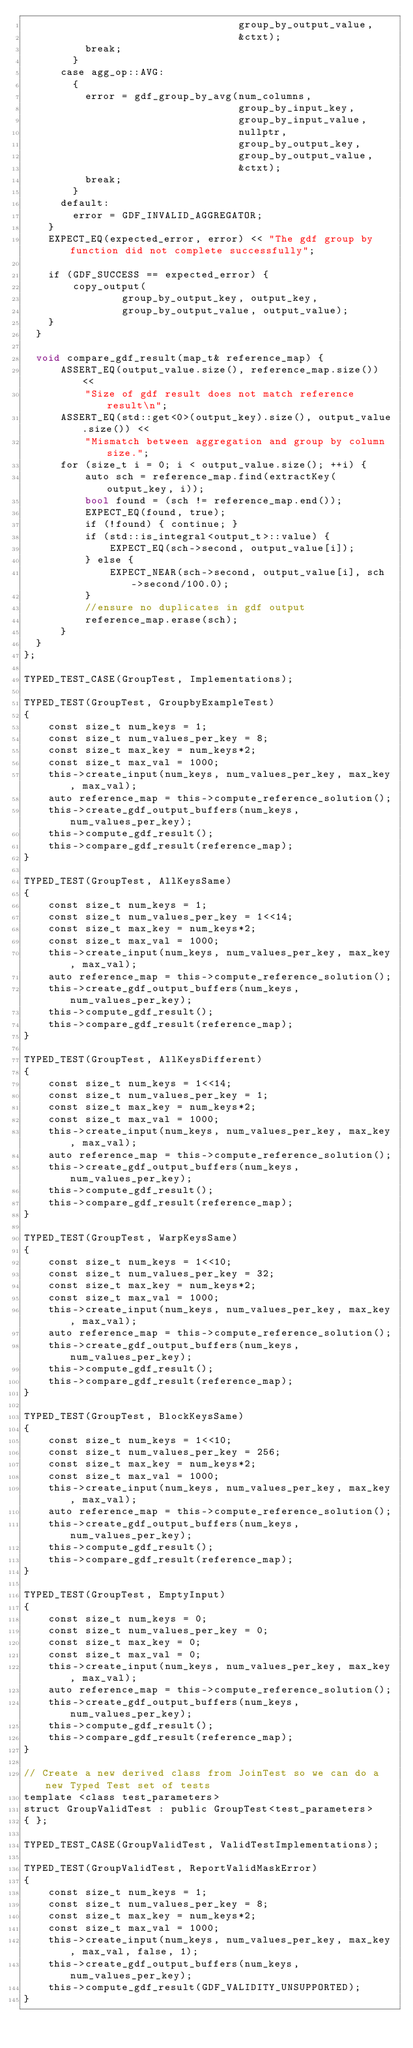<code> <loc_0><loc_0><loc_500><loc_500><_Cuda_>                                   group_by_output_value,
                                   &ctxt);
          break;
        }
      case agg_op::AVG:
        {
          error = gdf_group_by_avg(num_columns,
                                   group_by_input_key,
                                   group_by_input_value,
                                   nullptr,
                                   group_by_output_key,
                                   group_by_output_value,
                                   &ctxt);
          break;
        }
      default:
        error = GDF_INVALID_AGGREGATOR;
    }
    EXPECT_EQ(expected_error, error) << "The gdf group by function did not complete successfully";

    if (GDF_SUCCESS == expected_error) {
        copy_output(
                group_by_output_key, output_key,
                group_by_output_value, output_value);
    }
  }

  void compare_gdf_result(map_t& reference_map) {
      ASSERT_EQ(output_value.size(), reference_map.size()) <<
          "Size of gdf result does not match reference result\n";
      ASSERT_EQ(std::get<0>(output_key).size(), output_value.size()) <<
          "Mismatch between aggregation and group by column size.";
      for (size_t i = 0; i < output_value.size(); ++i) {
          auto sch = reference_map.find(extractKey(output_key, i));
          bool found = (sch != reference_map.end());
          EXPECT_EQ(found, true);
          if (!found) { continue; }
          if (std::is_integral<output_t>::value) {
              EXPECT_EQ(sch->second, output_value[i]);
          } else {
              EXPECT_NEAR(sch->second, output_value[i], sch->second/100.0);
          }
          //ensure no duplicates in gdf output
          reference_map.erase(sch);
      }
  }
};

TYPED_TEST_CASE(GroupTest, Implementations);

TYPED_TEST(GroupTest, GroupbyExampleTest)
{
    const size_t num_keys = 1;
    const size_t num_values_per_key = 8;
    const size_t max_key = num_keys*2;
    const size_t max_val = 1000;
    this->create_input(num_keys, num_values_per_key, max_key, max_val);
    auto reference_map = this->compute_reference_solution();
    this->create_gdf_output_buffers(num_keys, num_values_per_key);
    this->compute_gdf_result();
    this->compare_gdf_result(reference_map);
}

TYPED_TEST(GroupTest, AllKeysSame)
{
    const size_t num_keys = 1;
    const size_t num_values_per_key = 1<<14;
    const size_t max_key = num_keys*2;
    const size_t max_val = 1000;
    this->create_input(num_keys, num_values_per_key, max_key, max_val);
    auto reference_map = this->compute_reference_solution();
    this->create_gdf_output_buffers(num_keys, num_values_per_key);
    this->compute_gdf_result();
    this->compare_gdf_result(reference_map);
}

TYPED_TEST(GroupTest, AllKeysDifferent)
{
    const size_t num_keys = 1<<14;
    const size_t num_values_per_key = 1;
    const size_t max_key = num_keys*2;
    const size_t max_val = 1000;
    this->create_input(num_keys, num_values_per_key, max_key, max_val);
    auto reference_map = this->compute_reference_solution();
    this->create_gdf_output_buffers(num_keys, num_values_per_key);
    this->compute_gdf_result();
    this->compare_gdf_result(reference_map);
}

TYPED_TEST(GroupTest, WarpKeysSame)
{
    const size_t num_keys = 1<<10;
    const size_t num_values_per_key = 32;
    const size_t max_key = num_keys*2;
    const size_t max_val = 1000;
    this->create_input(num_keys, num_values_per_key, max_key, max_val);
    auto reference_map = this->compute_reference_solution();
    this->create_gdf_output_buffers(num_keys, num_values_per_key);
    this->compute_gdf_result();
    this->compare_gdf_result(reference_map);
}

TYPED_TEST(GroupTest, BlockKeysSame)
{
    const size_t num_keys = 1<<10;
    const size_t num_values_per_key = 256;
    const size_t max_key = num_keys*2;
    const size_t max_val = 1000;
    this->create_input(num_keys, num_values_per_key, max_key, max_val);
    auto reference_map = this->compute_reference_solution();
    this->create_gdf_output_buffers(num_keys, num_values_per_key);
    this->compute_gdf_result();
    this->compare_gdf_result(reference_map);
}

TYPED_TEST(GroupTest, EmptyInput)
{
    const size_t num_keys = 0;
    const size_t num_values_per_key = 0;
    const size_t max_key = 0;
    const size_t max_val = 0;
    this->create_input(num_keys, num_values_per_key, max_key, max_val);
    auto reference_map = this->compute_reference_solution();
    this->create_gdf_output_buffers(num_keys, num_values_per_key);
    this->compute_gdf_result();
    this->compare_gdf_result(reference_map);
}

// Create a new derived class from JoinTest so we can do a new Typed Test set of tests
template <class test_parameters>
struct GroupValidTest : public GroupTest<test_parameters>
{ };

TYPED_TEST_CASE(GroupValidTest, ValidTestImplementations);

TYPED_TEST(GroupValidTest, ReportValidMaskError)
{
    const size_t num_keys = 1;
    const size_t num_values_per_key = 8;
    const size_t max_key = num_keys*2;
    const size_t max_val = 1000;
    this->create_input(num_keys, num_values_per_key, max_key, max_val, false, 1);
    this->create_gdf_output_buffers(num_keys, num_values_per_key);
    this->compute_gdf_result(GDF_VALIDITY_UNSUPPORTED);
}
</code> 